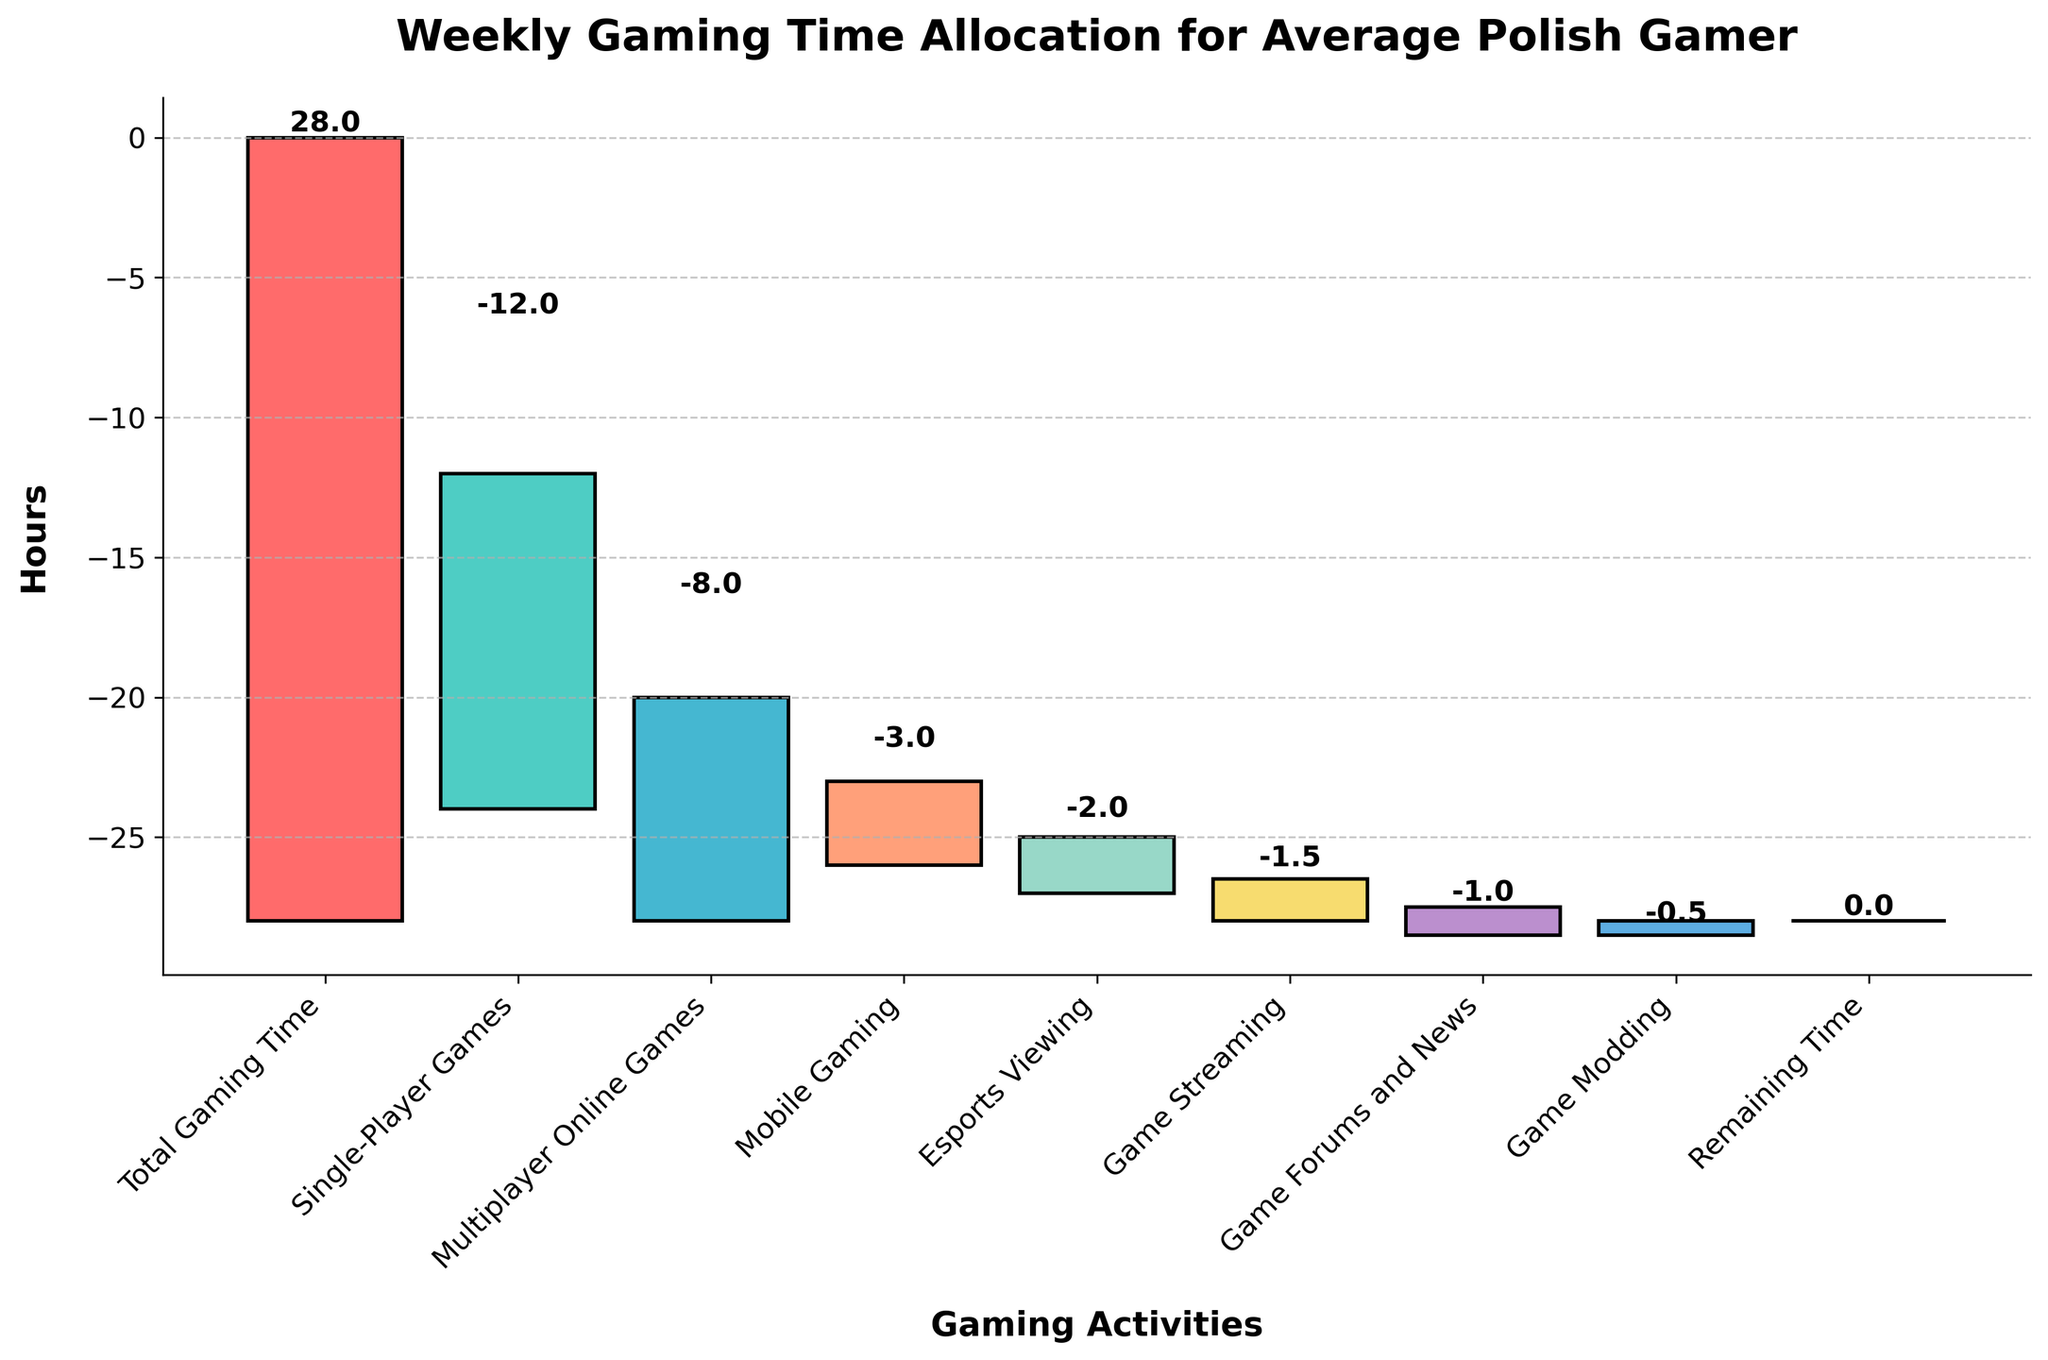What's the total gaming time allocated per week according to the chart? The figure title indicates weekly gaming time allocation, and the first bar labeled "Total Gaming Time" shows 28 hours.
Answer: 28 hours How many hours are spent on multiplayer online games? Look for the bar labeled "Multiplayer Online Games". The length of the bar shows -8 hours.
Answer: 8 hours Which activity takes up the most weekly gaming time after single-player games? Compare the bars for each activity. "Single-Player Games" is -12 hours, and the next highest bar is "Multiplayer Online Games" at -8 hours.
Answer: Multiplayer Online Games How much total time is spent on game forums and game modding combined? Look at the bars for "Game Forums and News" (-1 hour) and "Game Modding" (-0.5 hours). Sum these values: -1 + -0.5 = -1.5 hours.
Answer: 1.5 hours Which activity takes up the least amount of weekly gaming time? Look at the shortest bars indicating negative time values. "Game Modding" at -0.5 hours is the smallest.
Answer: Game Modding How many hours are allocated to esports viewing relative to game streaming? Look at the bars for "Esports Viewing" (-2 hours) and "Game Streaming" (-1.5 hours). The difference is: -2 - (-1.5) = -0.5 hours.
Answer: 0.5 hours more What's the cumulative time spent on single-player and multiplayer online games? Use the cumulative value for "Single-Player Games" (-12) and "Multiplayer Online Games" (-8). Add these: -12 - 8 = -20 hours.
Answer: 20 hours How many activities are listed in the chart? Count the number of distinct bars presented in the figure, including the total and remaining time. There are nine total bars.
Answer: 9 activities How does the time spent on watching esports compare to the time spent on mobile gaming? The bar for "Esports Viewing" shows -2 hours and for "Mobile Gaming" shows -3 hours. Esports Viewing takes less time.
Answer: Less time What's the difference between the total gaming time and the cumulative time spent on all listed activities? The last bar, "Remaining Time," gives an indication that cumulatively all activities add up to 28 hours, leaving 0 remaining.
Answer: 0 hours 